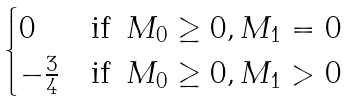<formula> <loc_0><loc_0><loc_500><loc_500>\begin{cases} 0 & \text {if } \, M _ { 0 } \geq 0 , M _ { 1 } = 0 \\ - \frac { 3 } { 4 } & \text {if } \, M _ { 0 } \geq 0 , M _ { 1 } > 0 \end{cases}</formula> 